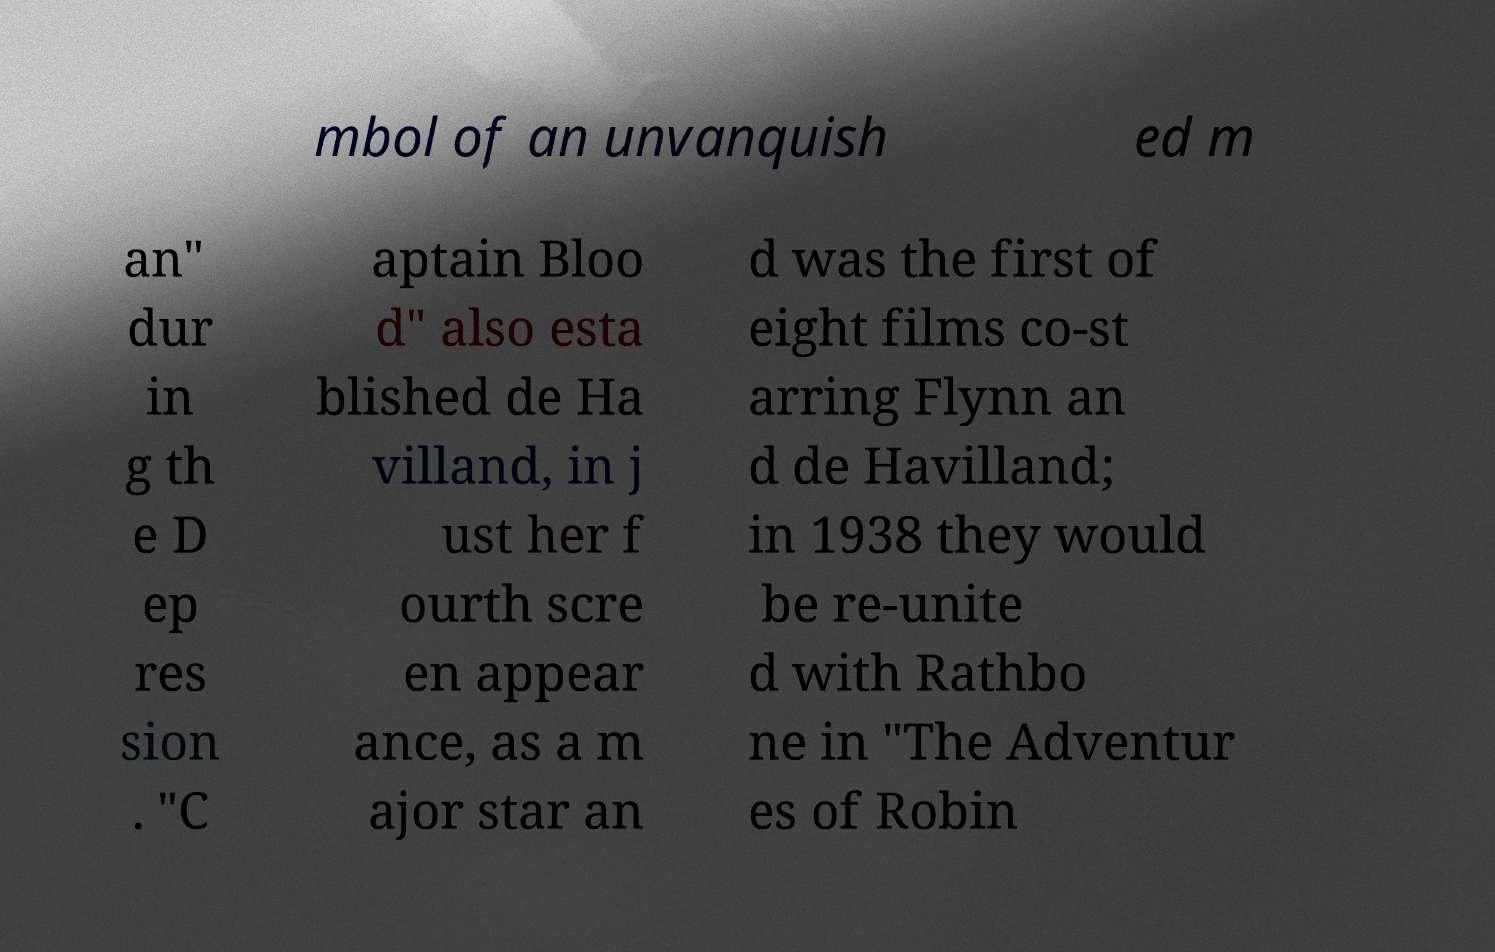Please read and relay the text visible in this image. What does it say? mbol of an unvanquish ed m an" dur in g th e D ep res sion . "C aptain Bloo d" also esta blished de Ha villand, in j ust her f ourth scre en appear ance, as a m ajor star an d was the first of eight films co-st arring Flynn an d de Havilland; in 1938 they would be re-unite d with Rathbo ne in "The Adventur es of Robin 